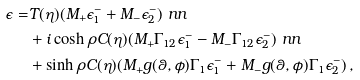Convert formula to latex. <formula><loc_0><loc_0><loc_500><loc_500>\epsilon = & T ( \eta ) ( M _ { + } \epsilon _ { 1 } ^ { - } + M _ { - } \epsilon _ { 2 } ^ { - } ) \ n n \\ & + i \cosh \rho C ( \eta ) ( M _ { + } \Gamma _ { 1 2 } \epsilon _ { 1 } ^ { - } - M _ { - } \Gamma _ { 1 2 } \epsilon _ { 2 } ^ { - } ) \ n n \\ & + \sinh \rho C ( \eta ) ( M _ { + } g ( \theta , \phi ) \Gamma _ { 1 } \epsilon _ { 1 } ^ { - } + M _ { - } g ( \theta , \phi ) \Gamma _ { 1 } \epsilon _ { 2 } ^ { - } ) \, ,</formula> 